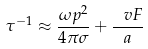Convert formula to latex. <formula><loc_0><loc_0><loc_500><loc_500>\tau ^ { - 1 } \approx \frac { \omega p ^ { 2 } } { 4 \pi \sigma } + \frac { \ v F } { a }</formula> 